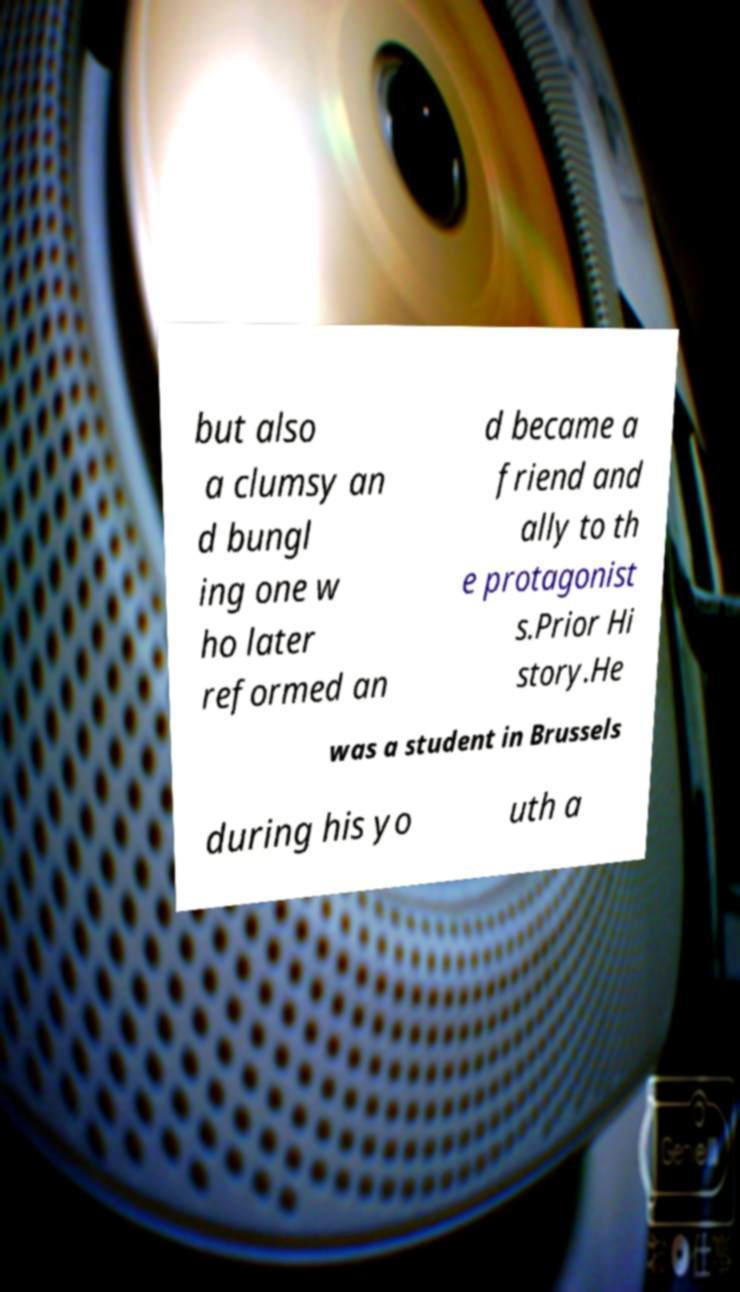I need the written content from this picture converted into text. Can you do that? but also a clumsy an d bungl ing one w ho later reformed an d became a friend and ally to th e protagonist s.Prior Hi story.He was a student in Brussels during his yo uth a 